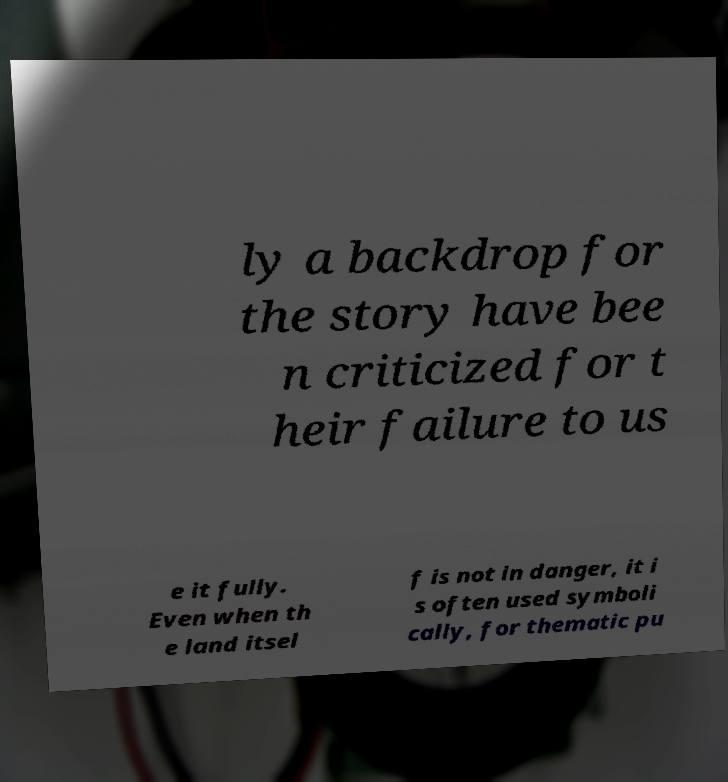I need the written content from this picture converted into text. Can you do that? ly a backdrop for the story have bee n criticized for t heir failure to us e it fully. Even when th e land itsel f is not in danger, it i s often used symboli cally, for thematic pu 